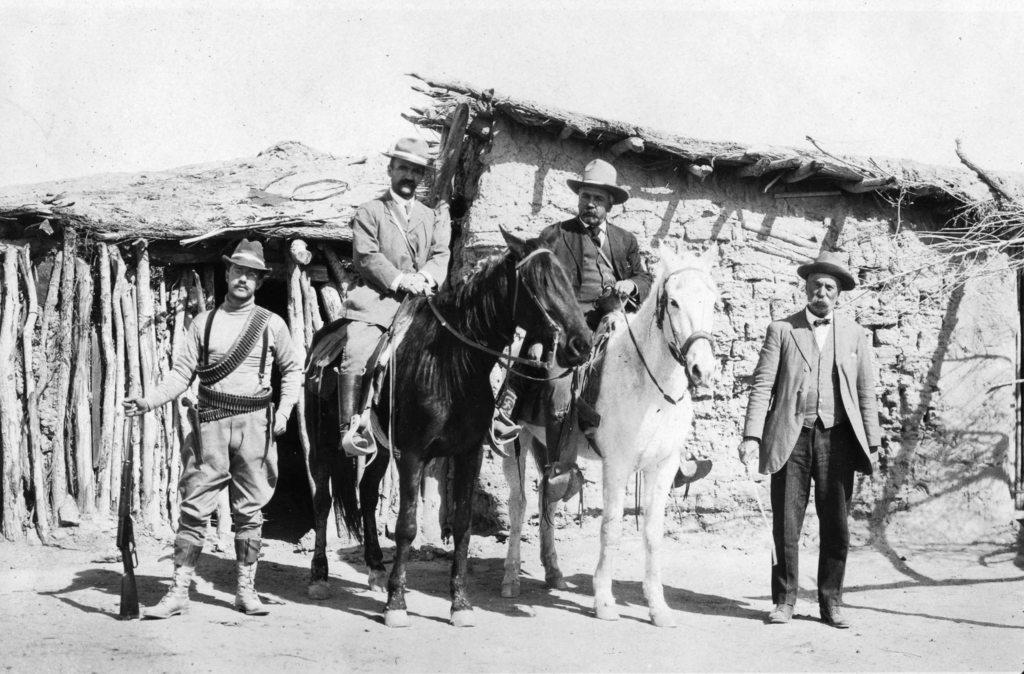What is happening in the image? There are people standing in the image, and two men are sitting on horses. What is the color scheme of the image? The image is in black and white color. How many lines can be seen in the image? There is no specific mention of lines in the image, so it is not possible to determine the number of lines present. 